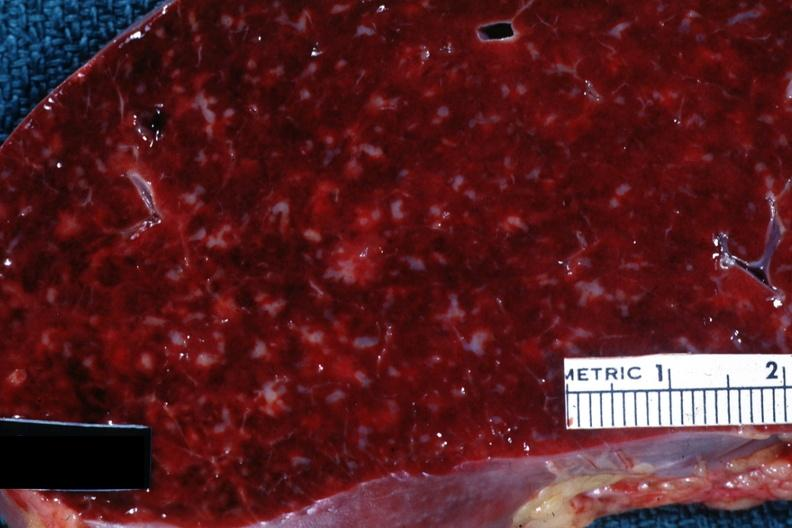what is present?
Answer the question using a single word or phrase. Spleen 